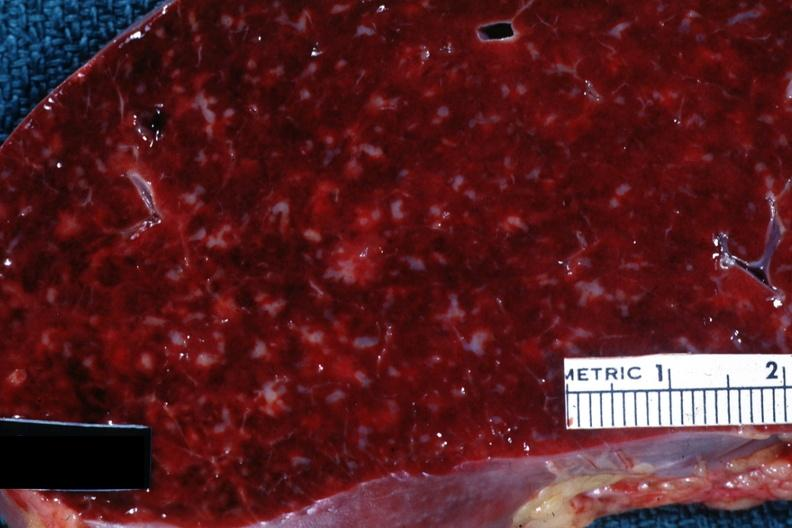what is present?
Answer the question using a single word or phrase. Spleen 